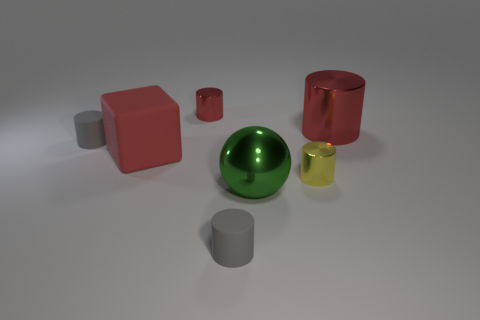Subtract all red cylinders. How many were subtracted if there are1red cylinders left? 1 Subtract all rubber cylinders. How many cylinders are left? 3 Subtract 2 cylinders. How many cylinders are left? 3 Add 1 large objects. How many objects exist? 8 Subtract all blocks. How many objects are left? 6 Subtract all red cylinders. How many cylinders are left? 3 Subtract 2 gray cylinders. How many objects are left? 5 Subtract all green cylinders. Subtract all green balls. How many cylinders are left? 5 Subtract all yellow balls. How many gray cylinders are left? 2 Subtract all metallic cylinders. Subtract all small metallic cylinders. How many objects are left? 2 